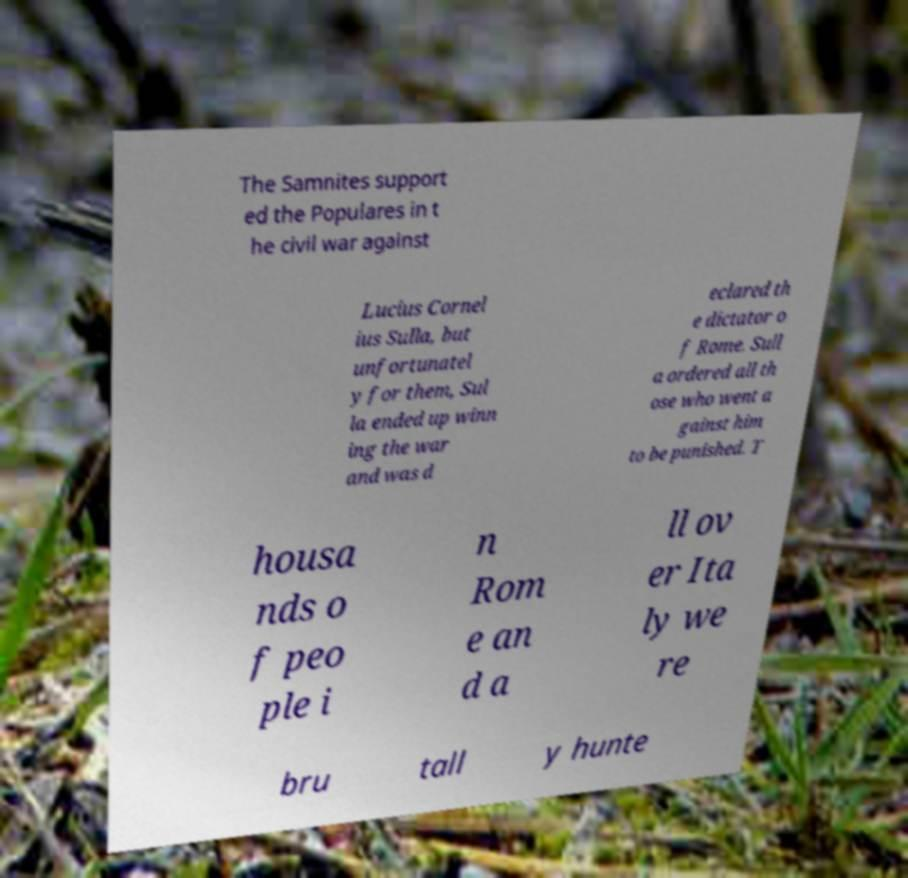Could you extract and type out the text from this image? The Samnites support ed the Populares in t he civil war against Lucius Cornel ius Sulla, but unfortunatel y for them, Sul la ended up winn ing the war and was d eclared th e dictator o f Rome. Sull a ordered all th ose who went a gainst him to be punished. T housa nds o f peo ple i n Rom e an d a ll ov er Ita ly we re bru tall y hunte 